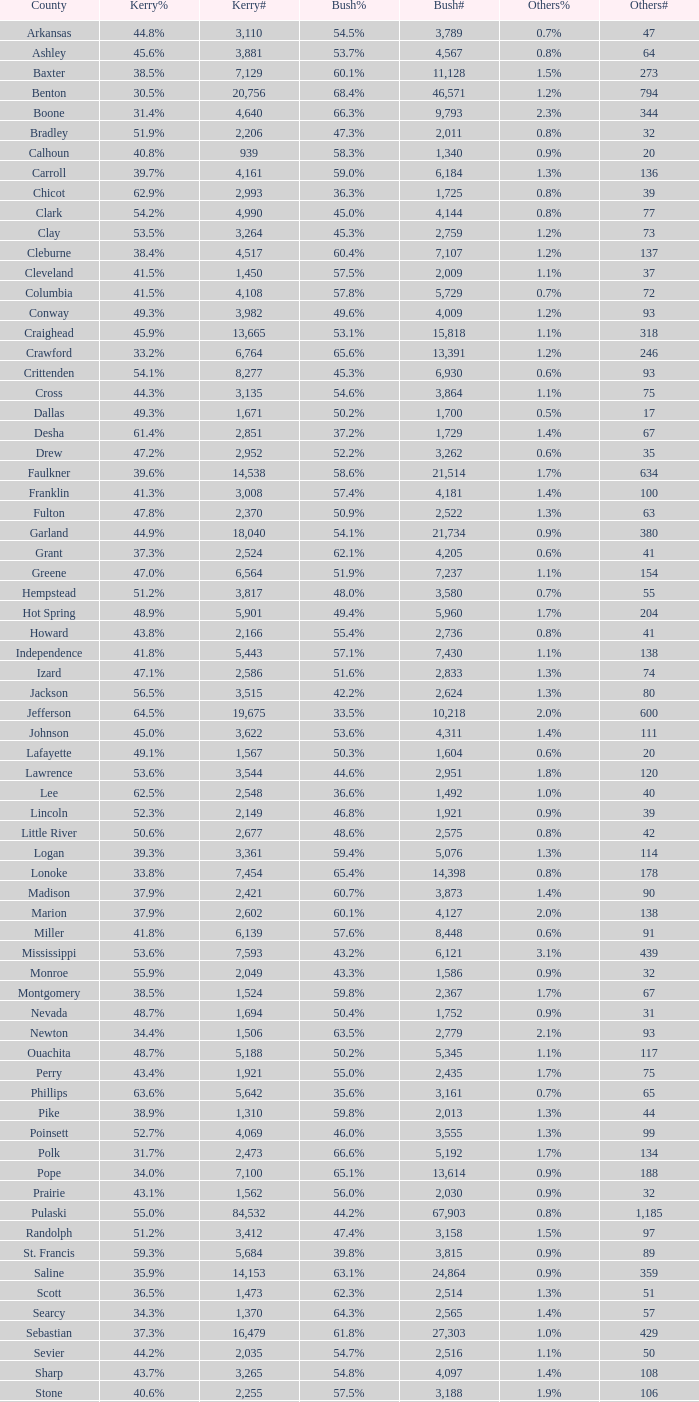7%", when others# is under 75, and when kerry# is more than 1,524? None. 